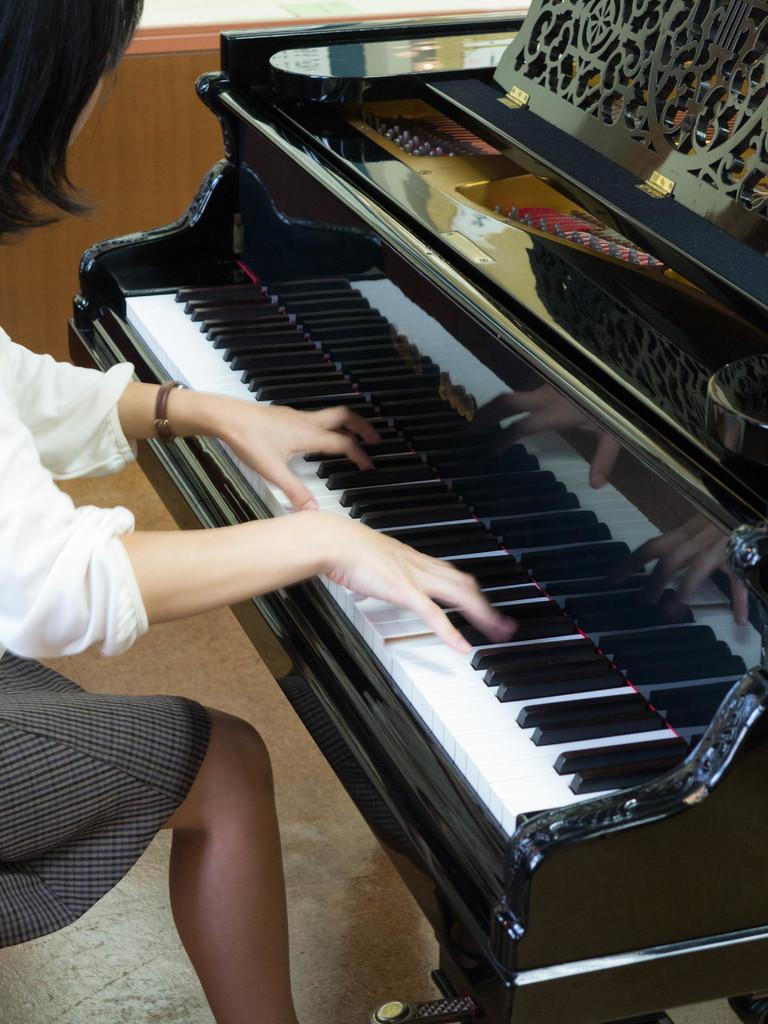What is the woman in the image doing? The woman is playing the piano. What is the woman wearing in the image? The woman is wearing a white dress. What message is the woman conveying with her love and good-bye in the image? There is no indication of love or good-bye in the image; it only shows a woman playing the piano while wearing a white dress. 